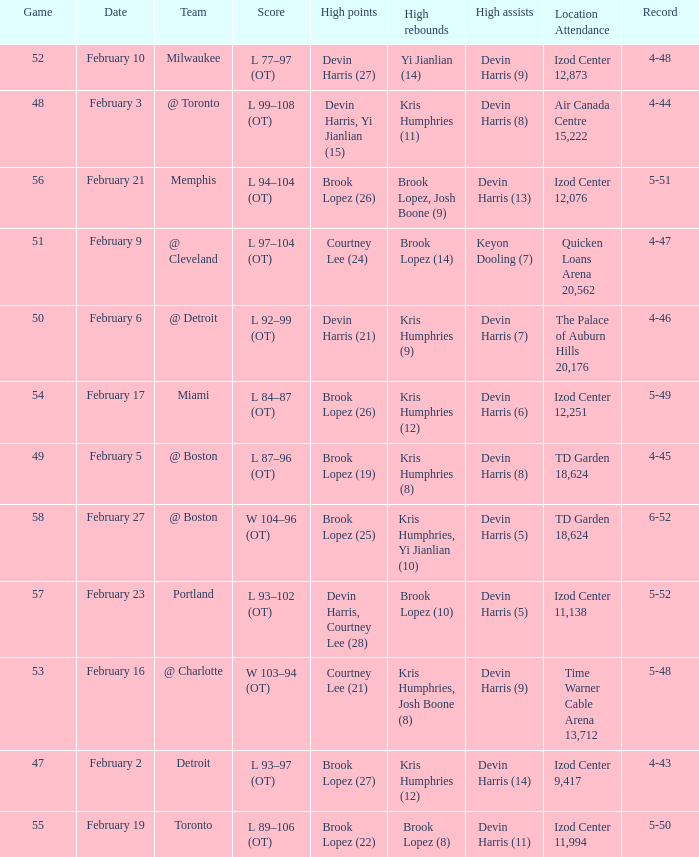What's the highest game number for a game in which Kris Humphries (8) did the high rebounds? 49.0. 